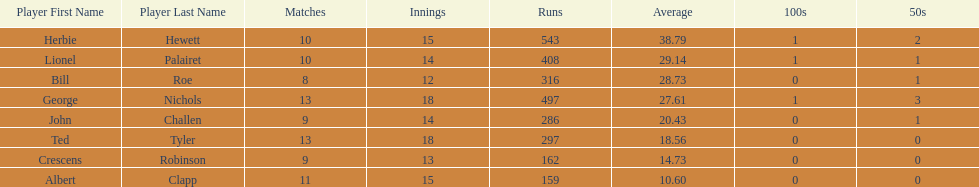What were the number of innings albert clapp had? 15. 